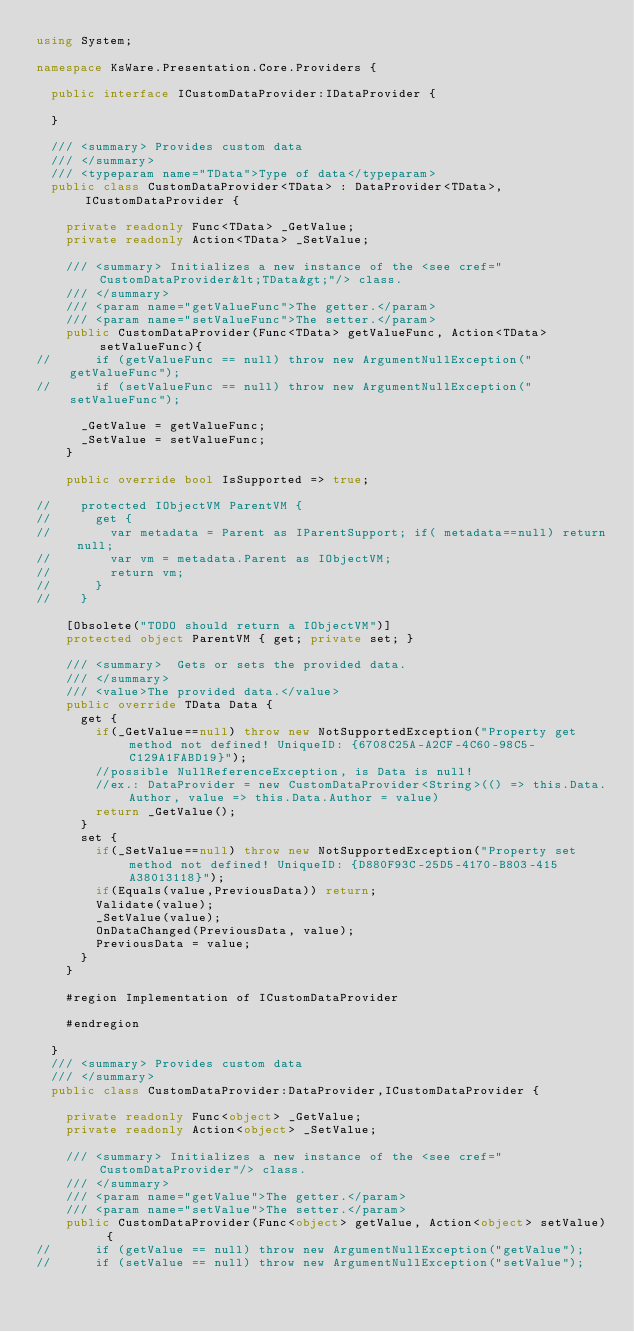Convert code to text. <code><loc_0><loc_0><loc_500><loc_500><_C#_>using System;

namespace KsWare.Presentation.Core.Providers {

	public interface ICustomDataProvider:IDataProvider {
		
	}

	/// <summary> Provides custom data
	/// </summary>
	/// <typeparam name="TData">Type of data</typeparam>
	public class CustomDataProvider<TData> : DataProvider<TData>, ICustomDataProvider {

		private readonly Func<TData> _GetValue;
		private readonly Action<TData> _SetValue;

		/// <summary> Initializes a new instance of the <see cref="CustomDataProvider&lt;TData&gt;"/> class.
		/// </summary>
		/// <param name="getValueFunc">The getter.</param>
		/// <param name="setValueFunc">The setter.</param>
		public CustomDataProvider(Func<TData> getValueFunc, Action<TData> setValueFunc){
//			if (getValueFunc == null) throw new ArgumentNullException("getValueFunc");
//			if (setValueFunc == null) throw new ArgumentNullException("setValueFunc");

			_GetValue = getValueFunc;
			_SetValue = setValueFunc;
		}

		public override bool IsSupported => true;

//		protected IObjectVM ParentVM {
//			get {
//				var metadata = Parent as IParentSupport; if( metadata==null) return null;
//				var vm = metadata.Parent as IObjectVM;
//				return vm;
//			}
//		}

		[Obsolete("TODO should return a IObjectVM")]
		protected object ParentVM { get; private set; }

		/// <summary>  Gets or sets the provided data.
		/// </summary>
		/// <value>The provided data.</value>
		public override TData Data {
			get {
				if(_GetValue==null) throw new NotSupportedException("Property get method not defined! UniqueID: {6708C25A-A2CF-4C60-98C5-C129A1FABD19}");
				//possible NullReferenceException, is Data is null!
				//ex.: DataProvider = new CustomDataProvider<String>(() => this.Data.Author, value => this.Data.Author = value)
				return _GetValue();
			}
			set {
				if(_SetValue==null) throw new NotSupportedException("Property set method not defined! UniqueID: {D880F93C-25D5-4170-B803-415A38013118}");
				if(Equals(value,PreviousData)) return;
				Validate(value);
				_SetValue(value);
				OnDataChanged(PreviousData, value);
				PreviousData = value;
			}
		}

		#region Implementation of ICustomDataProvider

		#endregion

	}
	/// <summary> Provides custom data
	/// </summary>
	public class CustomDataProvider:DataProvider,ICustomDataProvider {

		private readonly Func<object> _GetValue;
		private readonly Action<object> _SetValue;

		/// <summary> Initializes a new instance of the <see cref="CustomDataProvider"/> class.
		/// </summary>
		/// <param name="getValue">The getter.</param>
		/// <param name="setValue">The setter.</param>
		public CustomDataProvider(Func<object> getValue, Action<object> setValue) {
//			if (getValue == null) throw new ArgumentNullException("getValue");
//			if (setValue == null) throw new ArgumentNullException("setValue");
</code> 